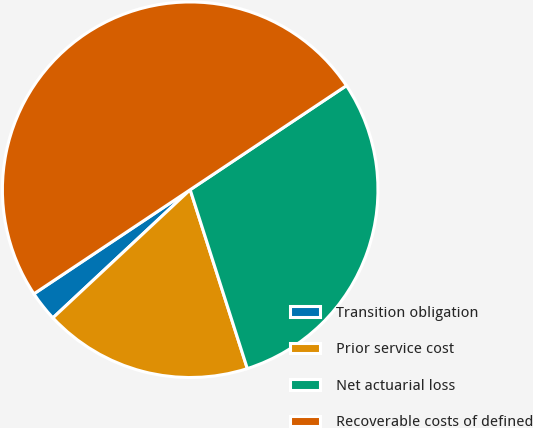Convert chart. <chart><loc_0><loc_0><loc_500><loc_500><pie_chart><fcel>Transition obligation<fcel>Prior service cost<fcel>Net actuarial loss<fcel>Recoverable costs of defined<nl><fcel>2.6%<fcel>17.97%<fcel>29.43%<fcel>50.0%<nl></chart> 